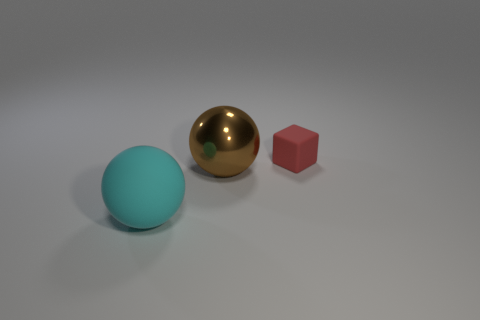Add 2 big red rubber balls. How many objects exist? 5 Subtract all balls. How many objects are left? 1 Subtract all tiny matte things. Subtract all cyan objects. How many objects are left? 1 Add 3 big cyan matte balls. How many big cyan matte balls are left? 4 Add 1 tiny green shiny cylinders. How many tiny green shiny cylinders exist? 1 Subtract 0 gray cubes. How many objects are left? 3 